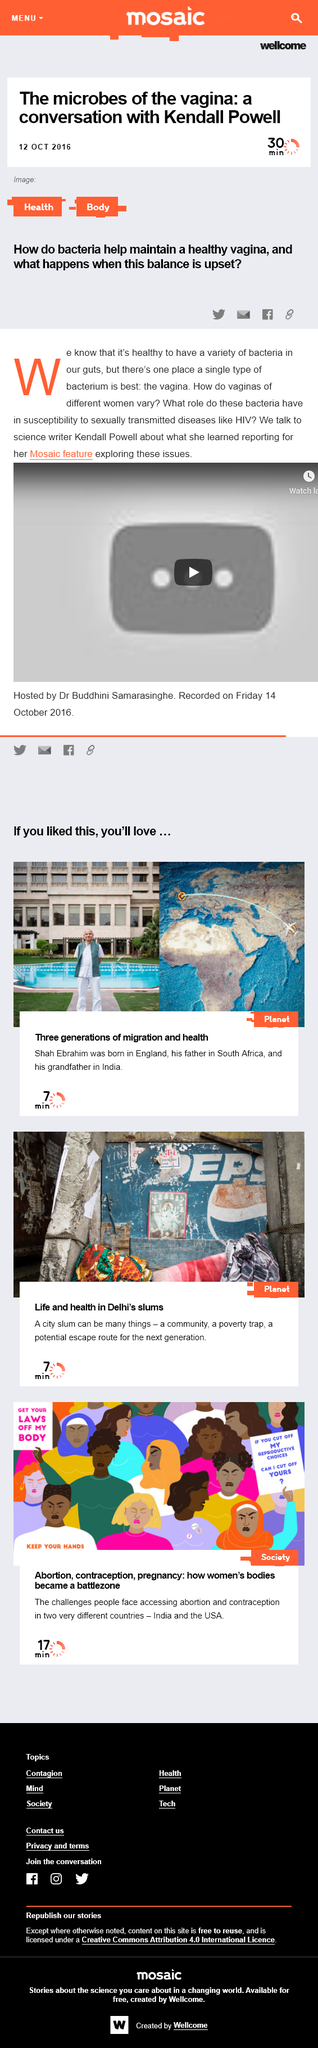Indicate a few pertinent items in this graphic. The article belongs in the body and health categories. The article was published on October 12th, 2016. The article can be shared through hyperlink, email, Facebook, and Twitter. 